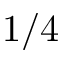<formula> <loc_0><loc_0><loc_500><loc_500>1 / 4</formula> 